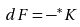Convert formula to latex. <formula><loc_0><loc_0><loc_500><loc_500>d F = - ^ { * } K</formula> 